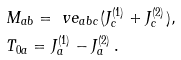<formula> <loc_0><loc_0><loc_500><loc_500>& M _ { a b } = \ v e _ { a b c } ( J ^ { ( 1 ) } _ { c } + J ^ { ( 2 ) } _ { c } ) , \\ & T _ { 0 a } = J ^ { ( 1 ) } _ { a } - J ^ { ( 2 ) } _ { a } \, .</formula> 